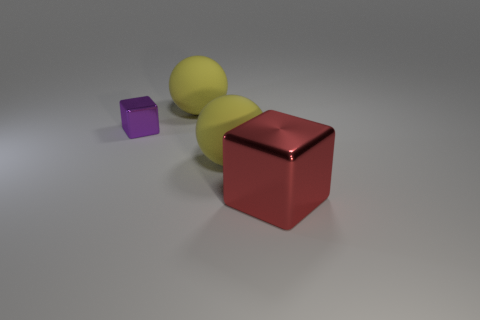Are there any other things that are the same size as the purple object?
Provide a short and direct response. No. Is there anything else that is the same color as the small block?
Ensure brevity in your answer.  No. What is the color of the large shiny object?
Give a very brief answer. Red. There is a yellow sphere that is behind the tiny purple object; is its size the same as the metallic object behind the big shiny cube?
Provide a succinct answer. No. Are there fewer metal blocks than objects?
Your response must be concise. Yes. What number of blocks are behind the big red block?
Provide a short and direct response. 1. Are there fewer tiny purple blocks right of the tiny cube than tiny purple shiny objects?
Your answer should be very brief. Yes. There is a metallic object that is left of the big metal block; what color is it?
Keep it short and to the point. Purple. The small metallic thing is what shape?
Your answer should be compact. Cube. Are there any red objects behind the yellow thing to the left of the large ball that is in front of the purple object?
Ensure brevity in your answer.  No. 